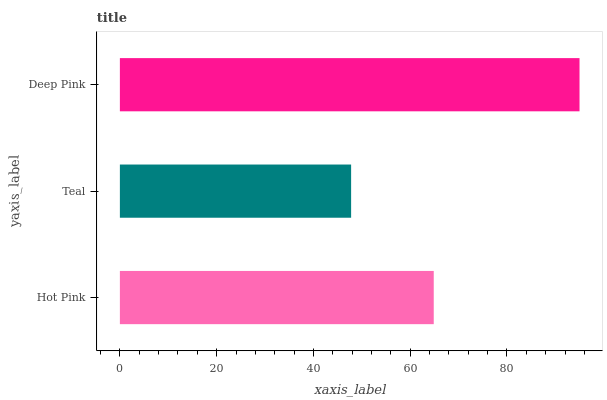Is Teal the minimum?
Answer yes or no. Yes. Is Deep Pink the maximum?
Answer yes or no. Yes. Is Deep Pink the minimum?
Answer yes or no. No. Is Teal the maximum?
Answer yes or no. No. Is Deep Pink greater than Teal?
Answer yes or no. Yes. Is Teal less than Deep Pink?
Answer yes or no. Yes. Is Teal greater than Deep Pink?
Answer yes or no. No. Is Deep Pink less than Teal?
Answer yes or no. No. Is Hot Pink the high median?
Answer yes or no. Yes. Is Hot Pink the low median?
Answer yes or no. Yes. Is Teal the high median?
Answer yes or no. No. Is Deep Pink the low median?
Answer yes or no. No. 